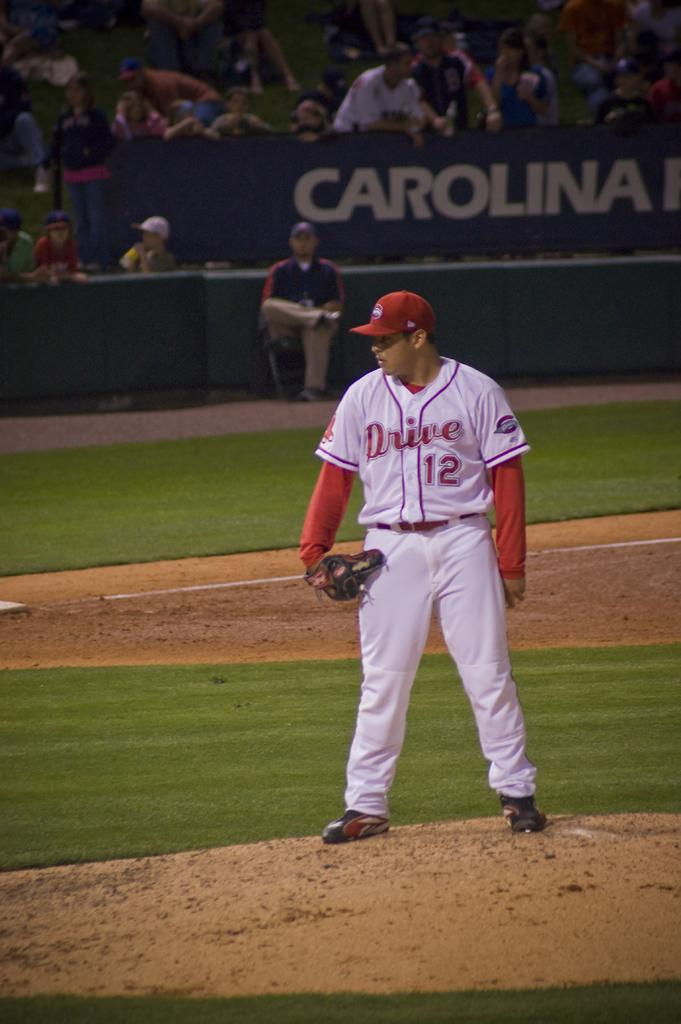Provide a one-sentence caption for the provided image. a baseball player with a red uniform with drive 12 printed on it. 